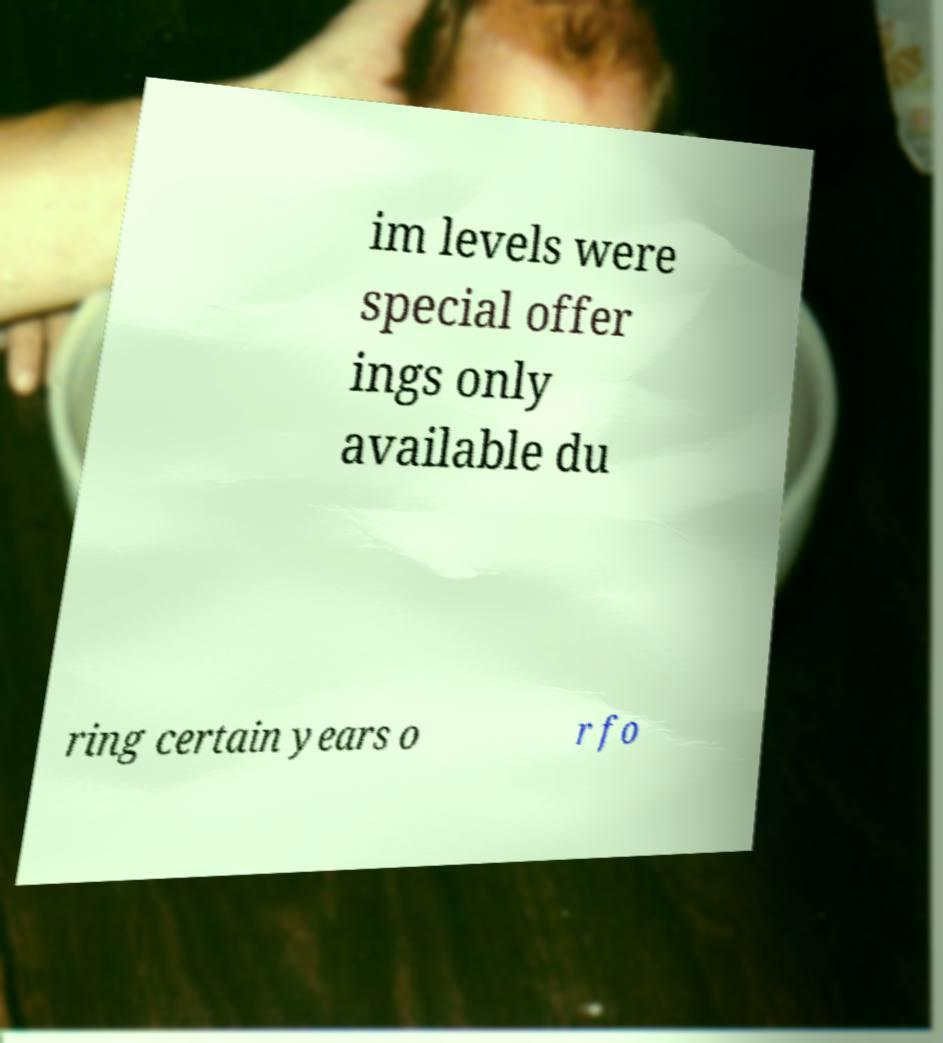I need the written content from this picture converted into text. Can you do that? im levels were special offer ings only available du ring certain years o r fo 